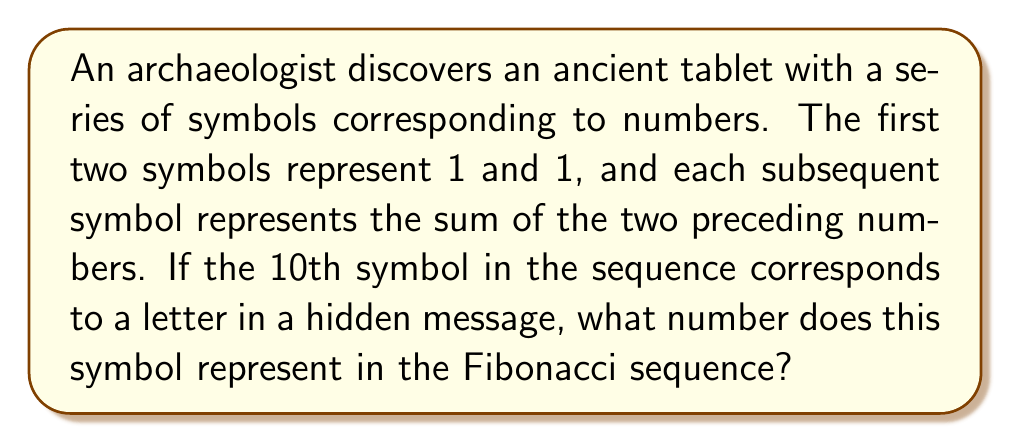Provide a solution to this math problem. To solve this problem, we need to generate the Fibonacci sequence up to the 10th term. The Fibonacci sequence is defined as follows:

1. The first two terms are 1 and 1.
2. Each subsequent term is the sum of the two preceding terms.

Let's calculate the sequence step by step:

1. $F_1 = 1$
2. $F_2 = 1$
3. $F_3 = F_1 + F_2 = 1 + 1 = 2$
4. $F_4 = F_2 + F_3 = 1 + 2 = 3$
5. $F_5 = F_3 + F_4 = 2 + 3 = 5$
6. $F_6 = F_4 + F_5 = 3 + 5 = 8$
7. $F_7 = F_5 + F_6 = 5 + 8 = 13$
8. $F_8 = F_6 + F_7 = 8 + 13 = 21$
9. $F_9 = F_7 + F_8 = 13 + 21 = 34$
10. $F_{10} = F_8 + F_9 = 21 + 34 = 55$

Therefore, the 10th symbol in the sequence represents the number 55 in the Fibonacci sequence.
Answer: 55 